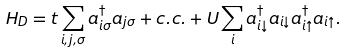<formula> <loc_0><loc_0><loc_500><loc_500>H _ { D } = t \sum _ { i , j , \sigma } a ^ { \dagger } _ { i \sigma } a _ { j \sigma } + c . c . + U \sum _ { i } a ^ { \dagger } _ { i \downarrow } a _ { i \downarrow } a ^ { \dagger } _ { i \uparrow } a _ { i \uparrow } .</formula> 